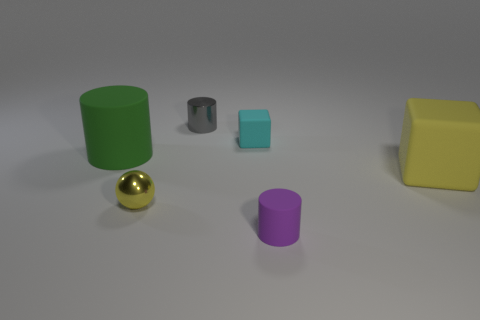What is the shape of the object in front of the small shiny object that is in front of the metallic cylinder?
Keep it short and to the point. Cylinder. Do the small metal sphere and the large rubber cube have the same color?
Ensure brevity in your answer.  Yes. Are there more tiny matte objects that are in front of the large cube than big cyan matte cylinders?
Offer a terse response. Yes. There is a tiny cylinder that is in front of the tiny gray metal cylinder; what number of gray cylinders are right of it?
Your answer should be compact. 0. Are the big object right of the big cylinder and the object in front of the small yellow shiny thing made of the same material?
Your response must be concise. Yes. What is the material of the thing that is the same color as the large matte cube?
Your answer should be very brief. Metal. What number of other tiny gray things have the same shape as the gray thing?
Give a very brief answer. 0. Are the small gray object and the yellow object on the left side of the small cyan matte cube made of the same material?
Provide a short and direct response. Yes. What is the material of the purple object that is the same size as the cyan cube?
Provide a short and direct response. Rubber. Are there any yellow metal blocks of the same size as the yellow shiny thing?
Offer a very short reply. No. 